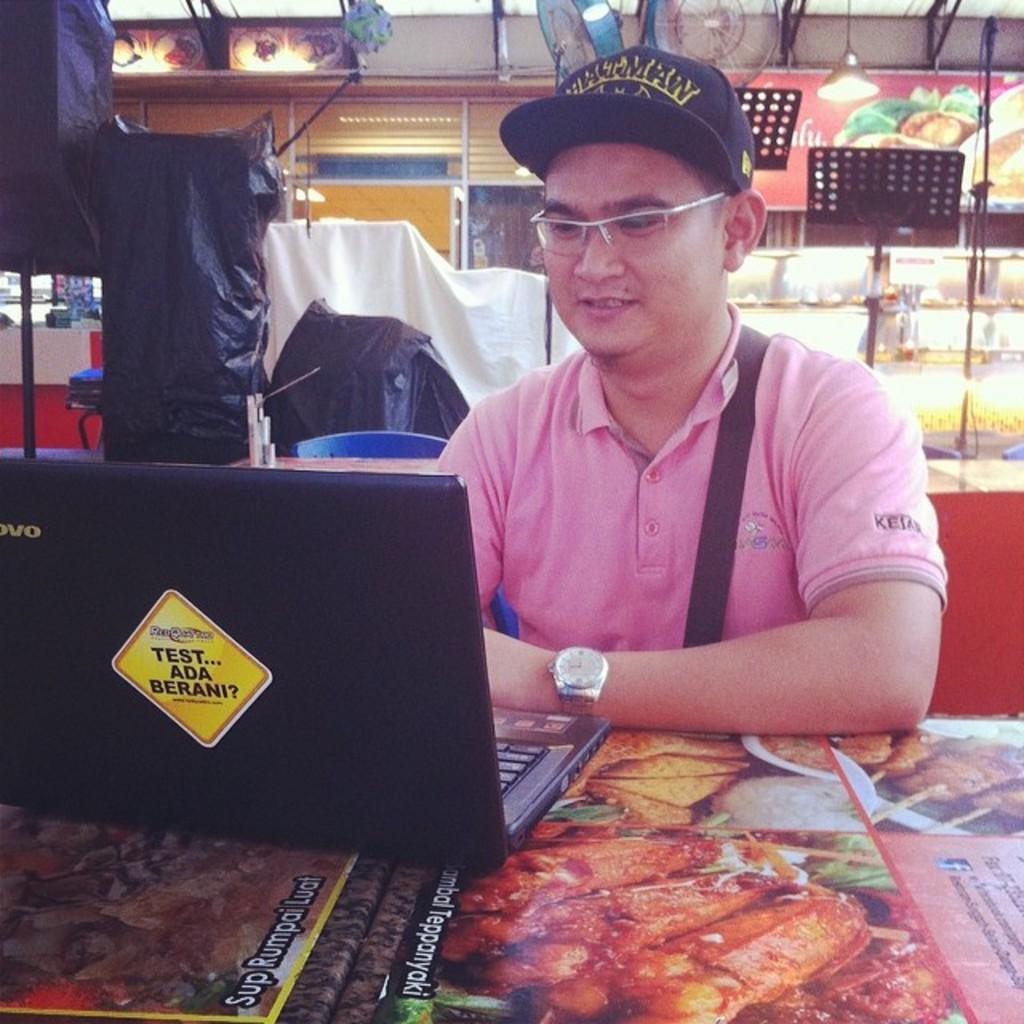Can you describe this image briefly? In this image I can see a man is wearing spectacles, a watch and a t-shirt. Here I can see a black color laptop on a table. In the background I can see some objects. 